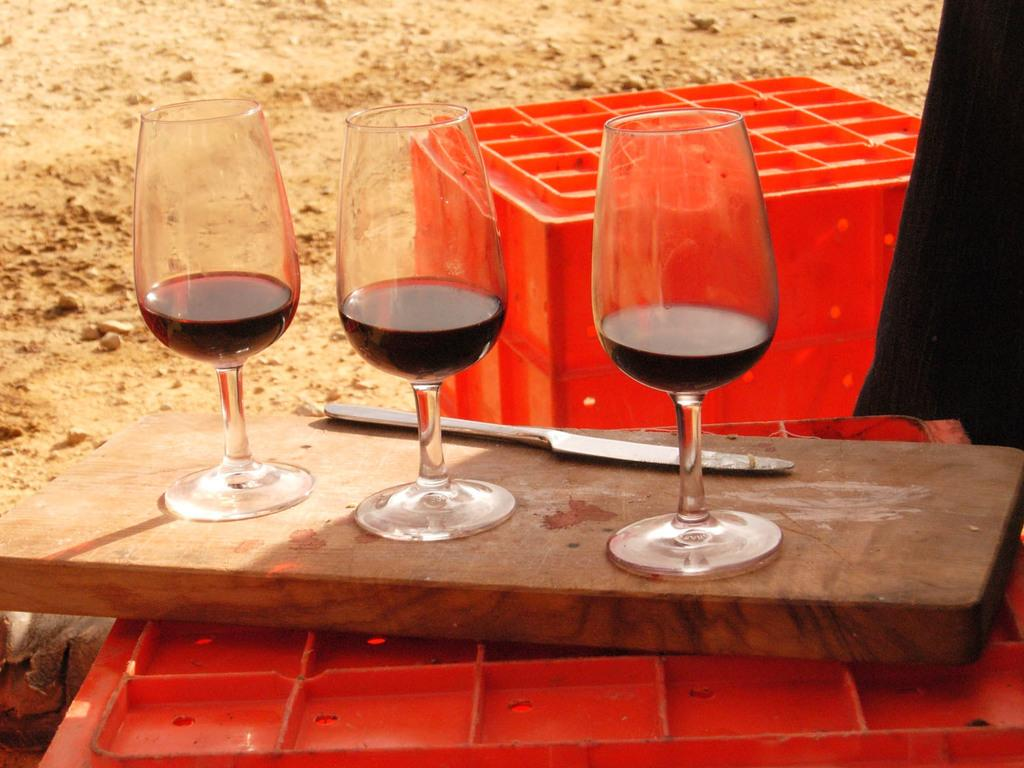How many glasses can be seen in the image? There are three glasses in the image. What is the knife placed on in the image? The knife is on a wooden board in the image. What type of containers are visible in the image? There are crates visible in the image. What else can be seen on the ground in the image? There are other objects on the ground in the image. Can you tell me how many bricks are stacked on the ground in the image? There is no mention of bricks in the image; the provided facts do not include any information about bricks. 